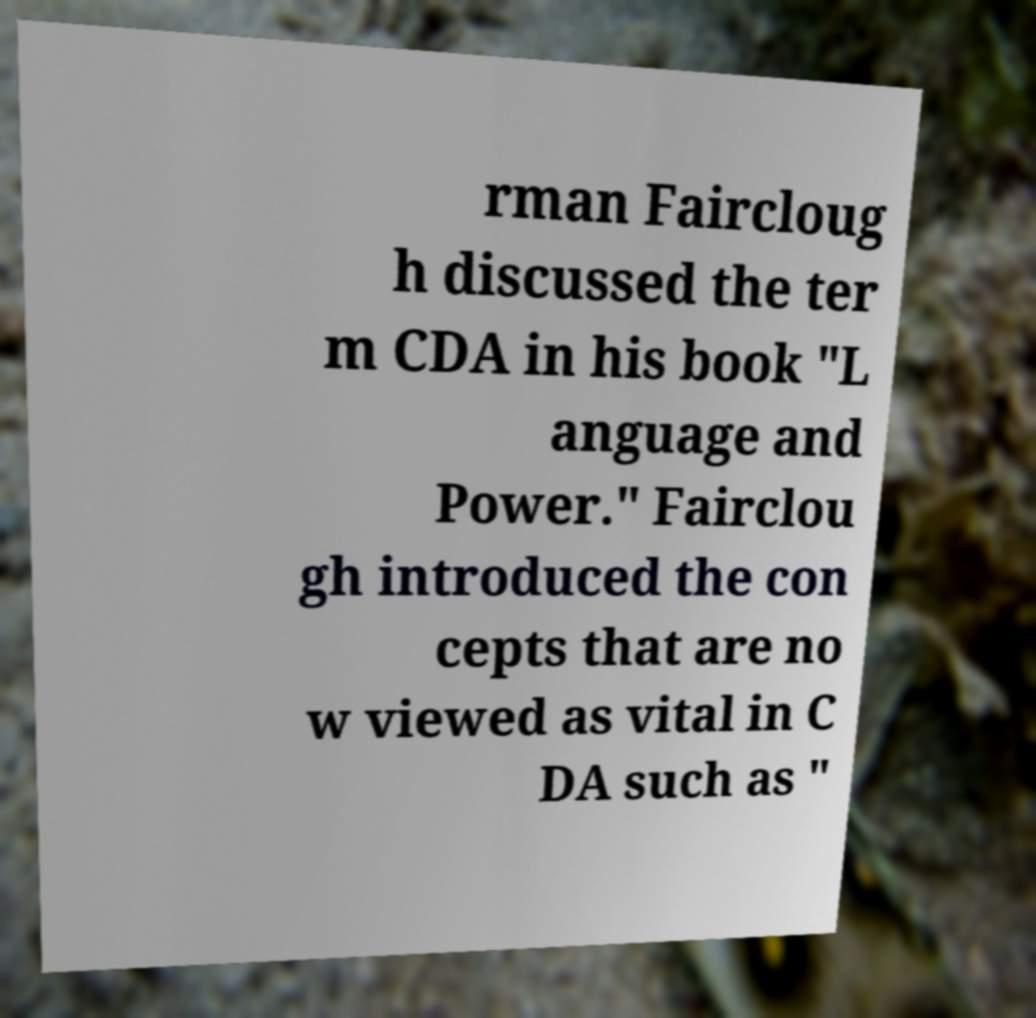There's text embedded in this image that I need extracted. Can you transcribe it verbatim? rman Faircloug h discussed the ter m CDA in his book "L anguage and Power." Fairclou gh introduced the con cepts that are no w viewed as vital in C DA such as " 